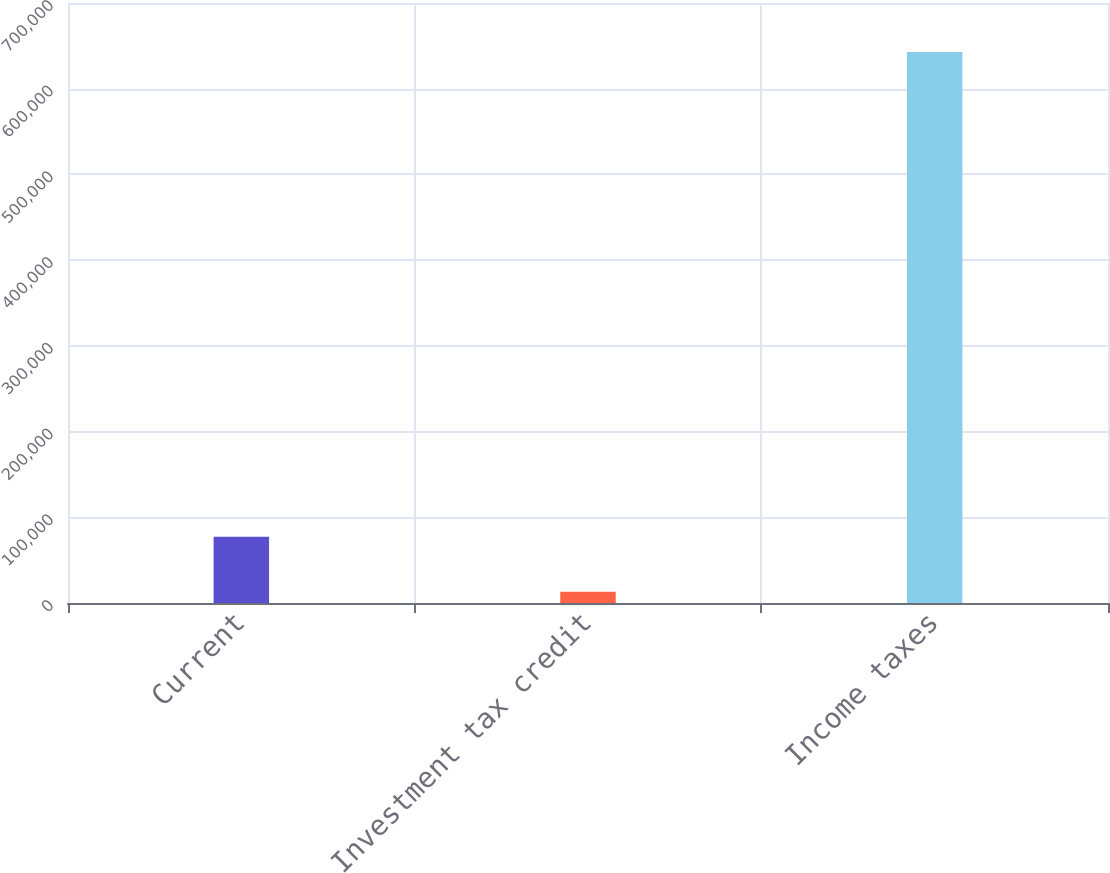Convert chart to OTSL. <chart><loc_0><loc_0><loc_500><loc_500><bar_chart><fcel>Current<fcel>Investment tax credit<fcel>Income taxes<nl><fcel>77166<fcel>13220<fcel>642927<nl></chart> 